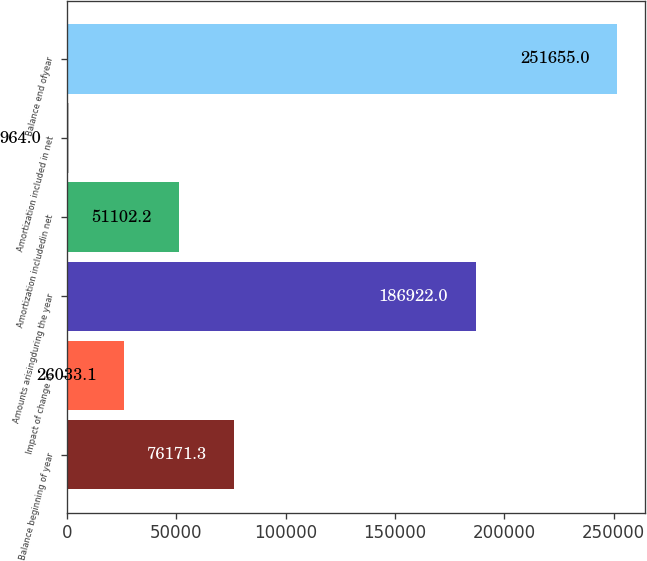<chart> <loc_0><loc_0><loc_500><loc_500><bar_chart><fcel>Balance beginning of year<fcel>Impact of change in<fcel>Amounts arisingduring the year<fcel>Amortization includedin net<fcel>Amortization included in net<fcel>Balance end ofyear<nl><fcel>76171.3<fcel>26033.1<fcel>186922<fcel>51102.2<fcel>964<fcel>251655<nl></chart> 